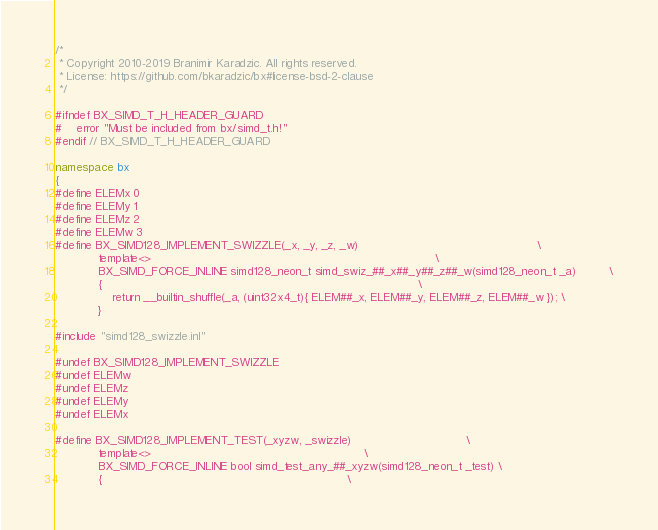<code> <loc_0><loc_0><loc_500><loc_500><_C++_>/*
 * Copyright 2010-2019 Branimir Karadzic. All rights reserved.
 * License: https://github.com/bkaradzic/bx#license-bsd-2-clause
 */

#ifndef BX_SIMD_T_H_HEADER_GUARD
#	error "Must be included from bx/simd_t.h!"
#endif // BX_SIMD_T_H_HEADER_GUARD

namespace bx
{
#define ELEMx 0
#define ELEMy 1
#define ELEMz 2
#define ELEMw 3
#define BX_SIMD128_IMPLEMENT_SWIZZLE(_x, _y, _z, _w)                                                  \
			template<>                                                                                \
			BX_SIMD_FORCE_INLINE simd128_neon_t simd_swiz_##_x##_y##_z##_w(simd128_neon_t _a)         \
			{                                                                                         \
				return __builtin_shuffle(_a, (uint32x4_t){ ELEM##_x, ELEM##_y, ELEM##_z, ELEM##_w }); \
			}

#include "simd128_swizzle.inl"

#undef BX_SIMD128_IMPLEMENT_SWIZZLE
#undef ELEMw
#undef ELEMz
#undef ELEMy
#undef ELEMx

#define BX_SIMD128_IMPLEMENT_TEST(_xyzw, _swizzle)                                \
			template<>                                                            \
			BX_SIMD_FORCE_INLINE bool simd_test_any_##_xyzw(simd128_neon_t _test) \
			{                                                                     \</code> 